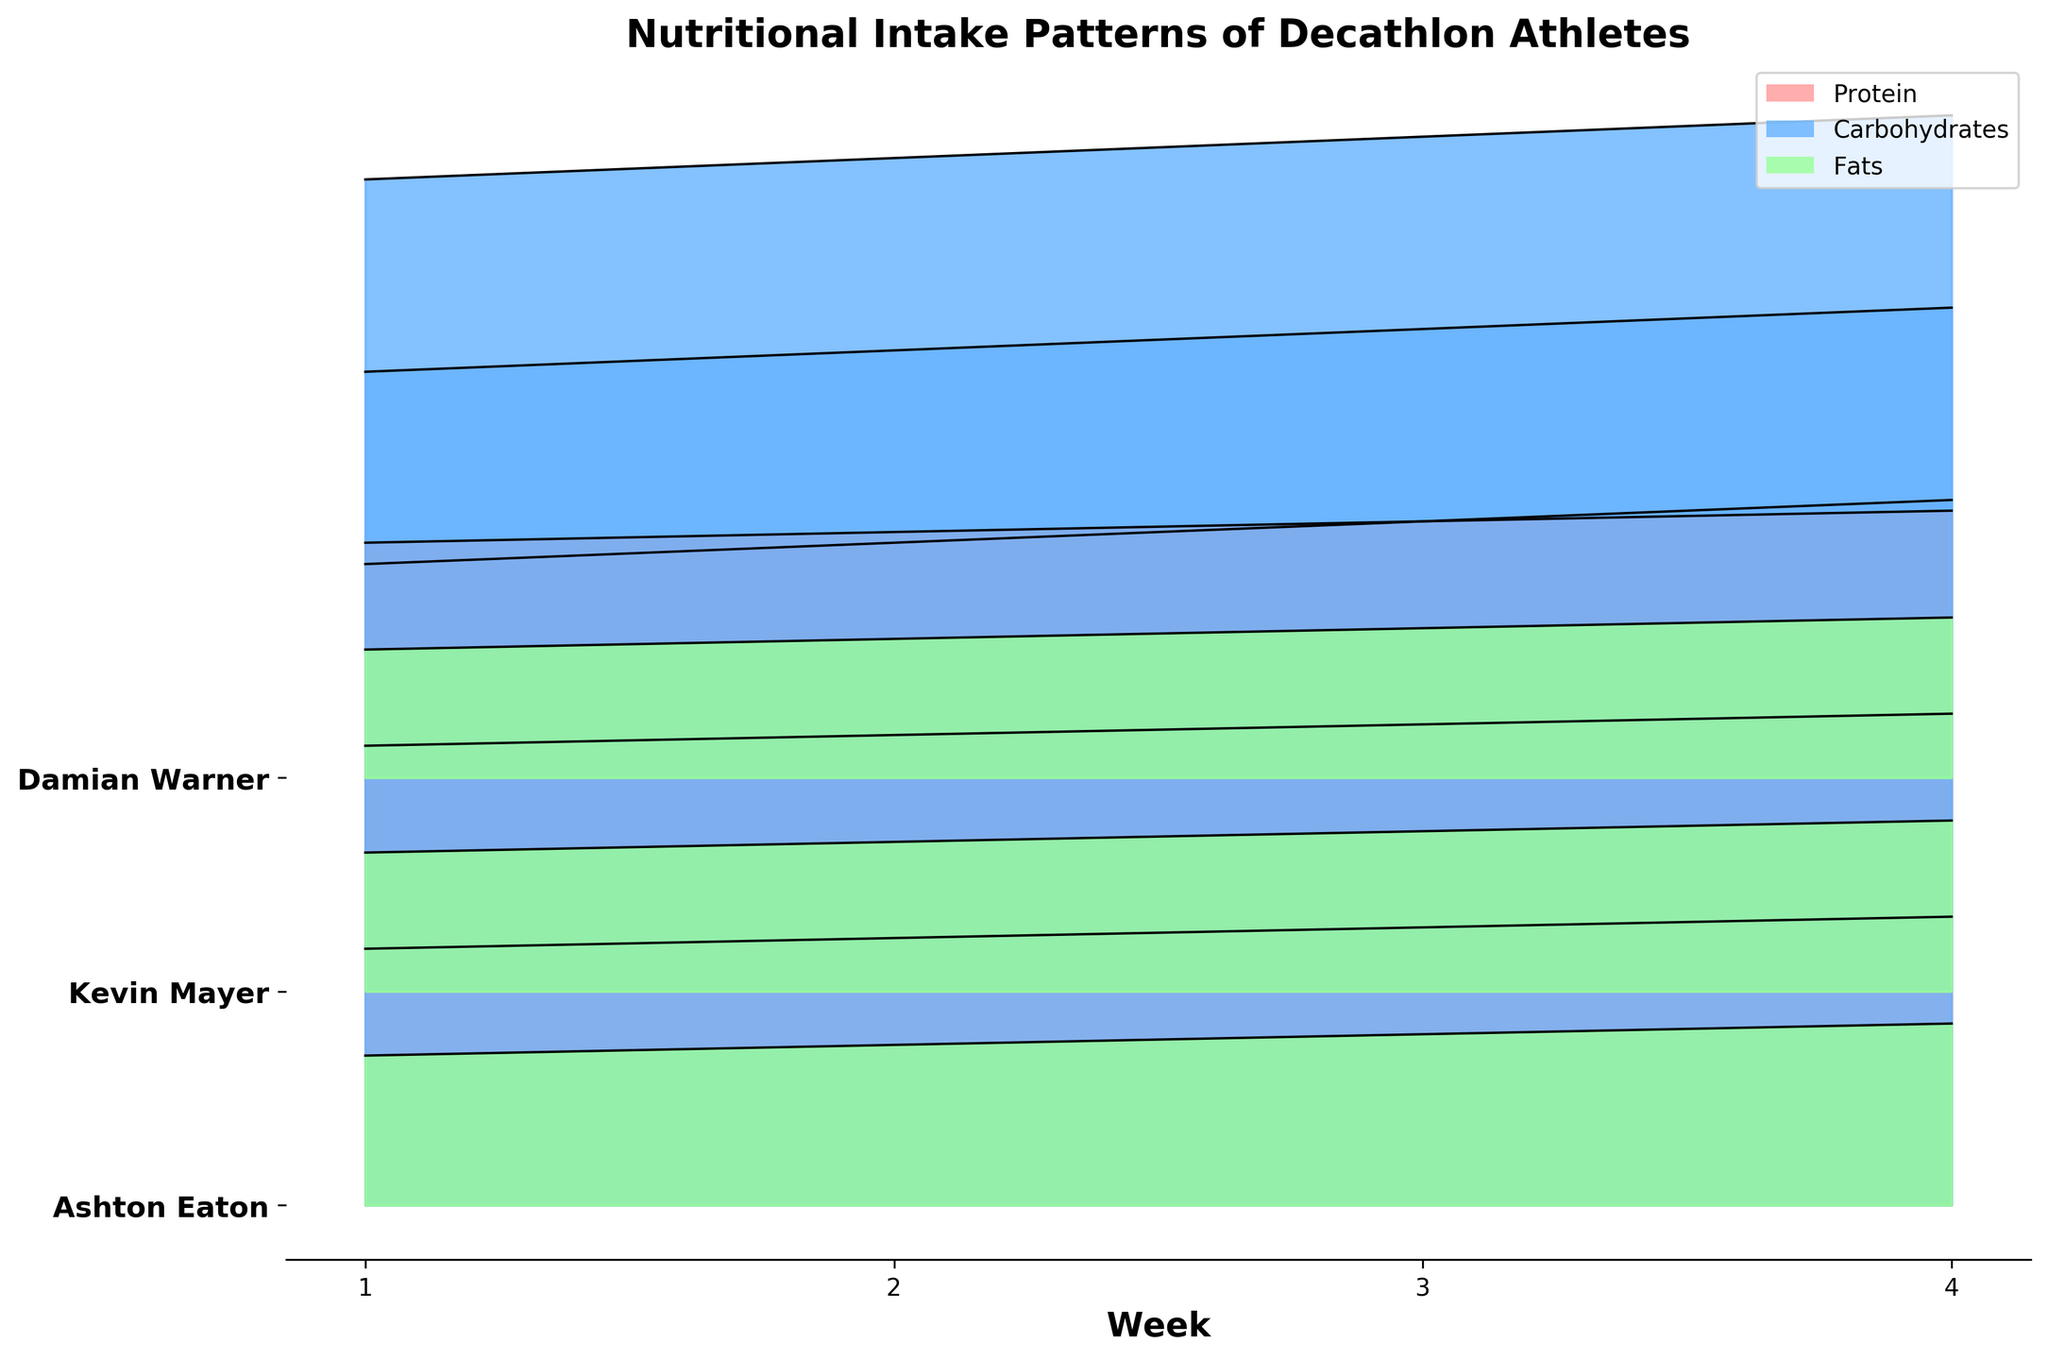What is the title of the figure? The title of the figure is prominently displayed at the top and usually provides a summary of the plot's insight. By reading the title, one can understand what the plot is about.
Answer: Nutritional Intake Patterns of Decathlon Athletes Which athlete has the highest protein intake in week 4? To answer this, look at the peaks of the protein intake lines in week 4 and identify the one that is the highest. Ashton Eaton's line reaches the highest value at week 4.
Answer: Ashton Eaton What is the color used to represent carbohydrates intake? Observe the legend in the upper right corner of the plot, which signifies various nutrients by different colors. The color representing carbohydrates is noted.
Answer: Blue How does Kevin Mayer's fat intake pattern change over the weeks? Track the fat intake area for Kevin Mayer by following the progression of the filled area for fats from week 1 to week 4, which rises consistently.
Answer: It increases consistently each week On average, how much do Ashton Eaton's protein intake values increase per week? To calculate the average increase: subtract the week 1 value from the week 4 value, then divide by 3 (since there are 3 intervals between 4 weeks). The values are 135 - 120 = 15. Average increase: 15 / 3 = 5.
Answer: 5 units Do all athletes show an increase in carbohydrate intake over time? Review the figure to see if the filled area for carbohydrates for all athletes is rising over the weeks. All athletes' carbohydrate intake areas are increasing over time.
Answer: Yes Which nutrient shows the least variation among all the athletes? Look at the differences in the heights of the areas for each nutrient across the athletes. Fat intake shows smaller and more consistent fills compared to proteins and carbohydrates.
Answer: Fats Which weeks show the steepest increase in protein intake for Damian Warner? Identify the weeks where the jump in line height is most significant for Damian Warner's protein intake. The steepest increase occurs between weeks 2 and 3.
Answer: Between weeks 2 and 3 Across the weeks, who has the lowest fat intake overall? Compare the filled areas representing fat intake for each athlete over all the weeks. Damian Warner consistently has the smallest filled areas for fats.
Answer: Damian Warner 